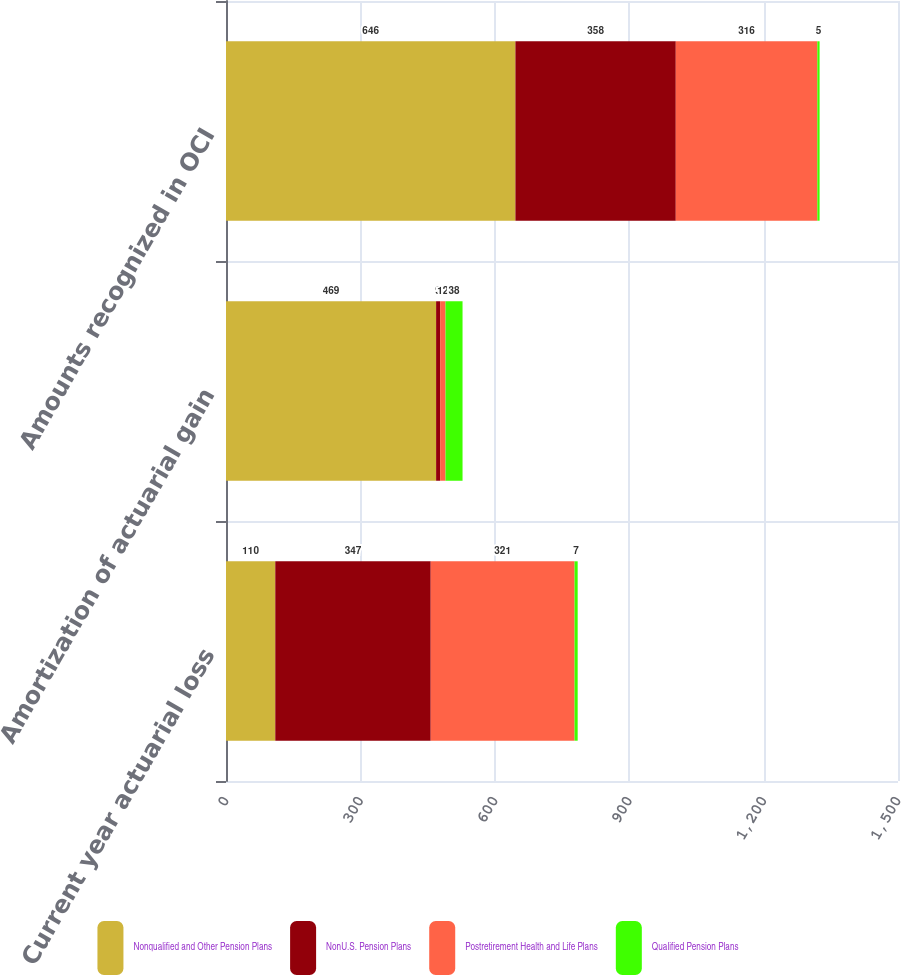Convert chart to OTSL. <chart><loc_0><loc_0><loc_500><loc_500><stacked_bar_chart><ecel><fcel>Current year actuarial loss<fcel>Amortization of actuarial gain<fcel>Amounts recognized in OCI<nl><fcel>Nonqualified and Other Pension Plans<fcel>110<fcel>469<fcel>646<nl><fcel>NonU.S. Pension Plans<fcel>347<fcel>9<fcel>358<nl><fcel>Postretirement Health and Life Plans<fcel>321<fcel>12<fcel>316<nl><fcel>Qualified Pension Plans<fcel>7<fcel>38<fcel>5<nl></chart> 